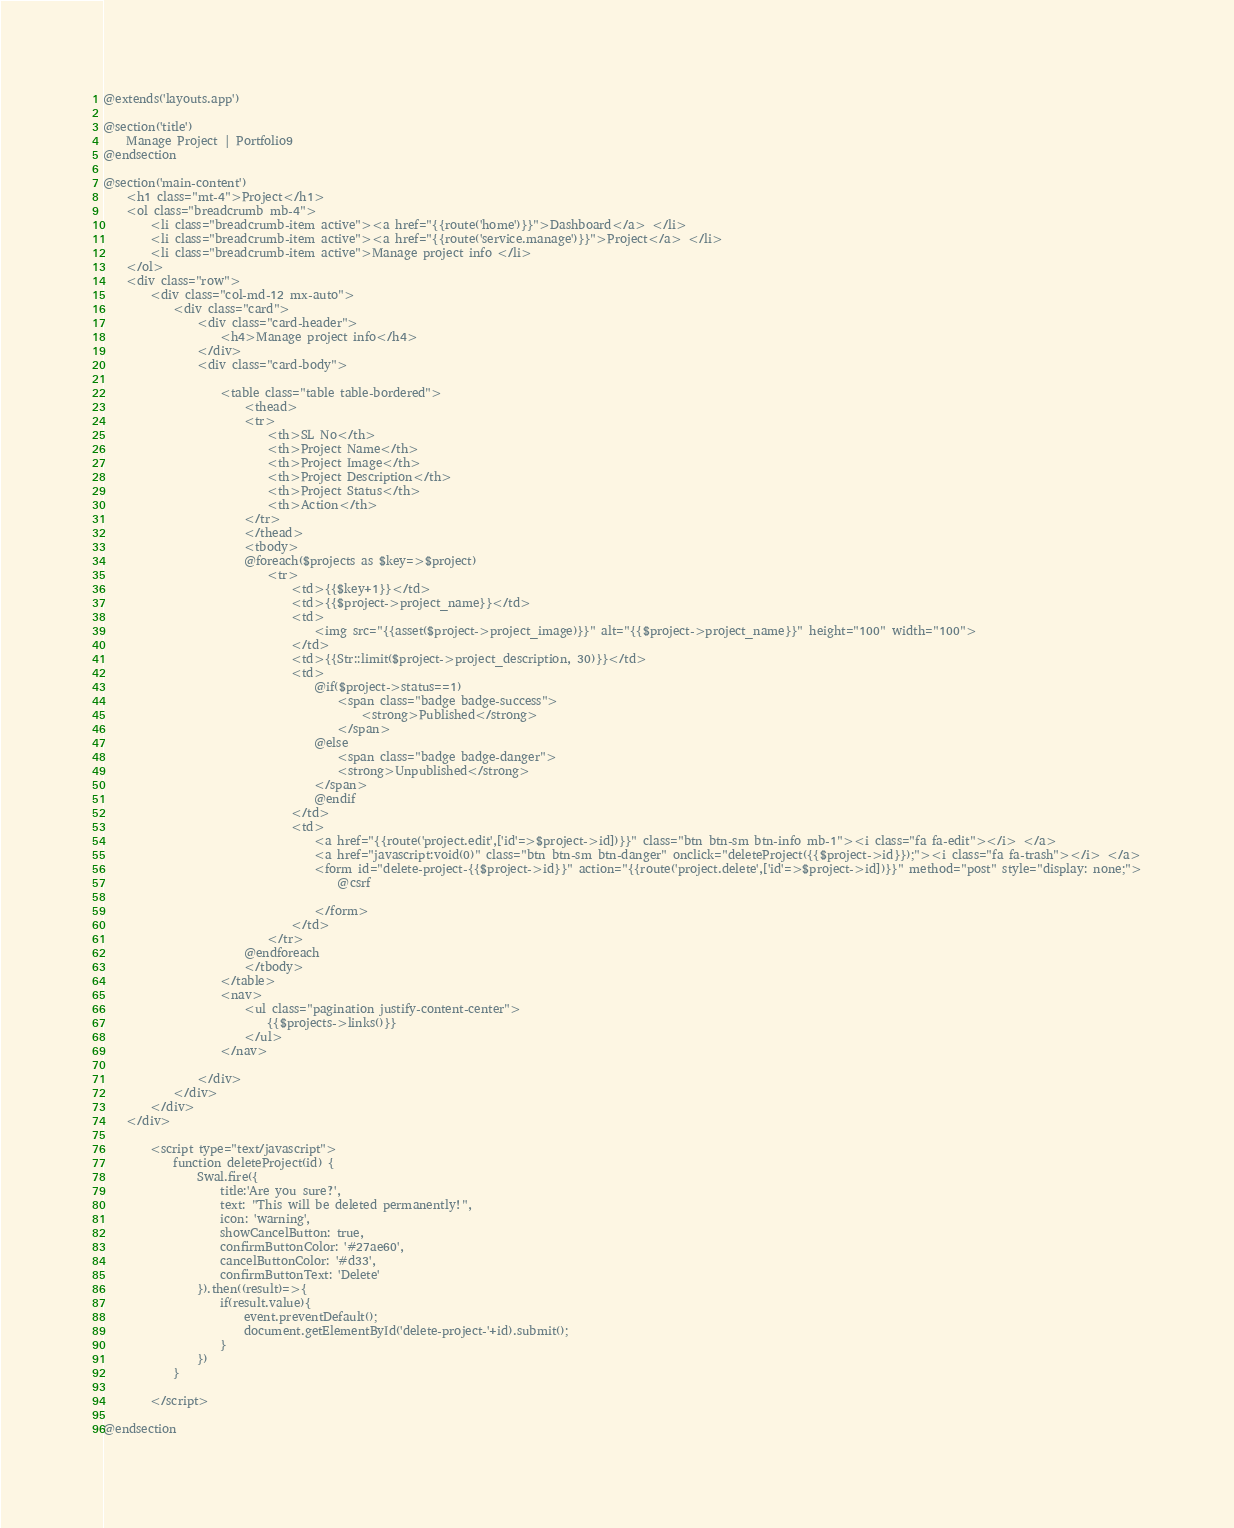<code> <loc_0><loc_0><loc_500><loc_500><_PHP_>@extends('layouts.app')

@section('title')
    Manage Project | Portfolio9
@endsection

@section('main-content')
    <h1 class="mt-4">Project</h1>
    <ol class="breadcrumb mb-4">
        <li class="breadcrumb-item active"><a href="{{route('home')}}">Dashboard</a> </li>
        <li class="breadcrumb-item active"><a href="{{route('service.manage')}}">Project</a> </li>
        <li class="breadcrumb-item active">Manage project info </li>
    </ol>
    <div class="row">
        <div class="col-md-12 mx-auto">
            <div class="card">
                <div class="card-header">
                    <h4>Manage project info</h4>
                </div>
                <div class="card-body">

                    <table class="table table-bordered">
                        <thead>
                        <tr>
                            <th>SL No</th>
                            <th>Project Name</th>
                            <th>Project Image</th>
                            <th>Project Description</th>
                            <th>Project Status</th>
                            <th>Action</th>
                        </tr>
                        </thead>
                        <tbody>
                        @foreach($projects as $key=>$project)
                            <tr>
                                <td>{{$key+1}}</td>
                                <td>{{$project->project_name}}</td>
                                <td>
                                    <img src="{{asset($project->project_image)}}" alt="{{$project->project_name}}" height="100" width="100">
                                </td>
                                <td>{{Str::limit($project->project_description, 30)}}</td>
                                <td>
                                    @if($project->status==1)
                                        <span class="badge badge-success">
                                            <strong>Published</strong>
                                        </span>
                                    @else
                                        <span class="badge badge-danger">
                                        <strong>Unpublished</strong>
                                    </span>
                                    @endif
                                </td>
                                <td>
                                    <a href="{{route('project.edit',['id'=>$project->id])}}" class="btn btn-sm btn-info mb-1"><i class="fa fa-edit"></i> </a>
                                    <a href="javascript:void(0)" class="btn btn-sm btn-danger" onclick="deleteProject({{$project->id}});"><i class="fa fa-trash"></i> </a>
                                    <form id="delete-project-{{$project->id}}" action="{{route('project.delete',['id'=>$project->id])}}" method="post" style="display: none;">
                                        @csrf

                                    </form>
                                </td>
                            </tr>
                        @endforeach
                        </tbody>
                    </table>
                    <nav>
                        <ul class="pagination justify-content-center">
                            {{$projects->links()}}
                        </ul>
                    </nav>

                </div>
            </div>
        </div>
    </div>

        <script type="text/javascript">
            function deleteProject(id) {
                Swal.fire({
                    title:'Are you sure?',
                    text: "This will be deleted permanently!",
                    icon: 'warning',
                    showCancelButton: true,
                    confirmButtonColor: '#27ae60',
                    cancelButtonColor: '#d33',
                    confirmButtonText: 'Delete'
                }).then((result)=>{
                    if(result.value){
                        event.preventDefault();
                        document.getElementById('delete-project-'+id).submit();
                    }
                })
            }

        </script>

@endsection

</code> 